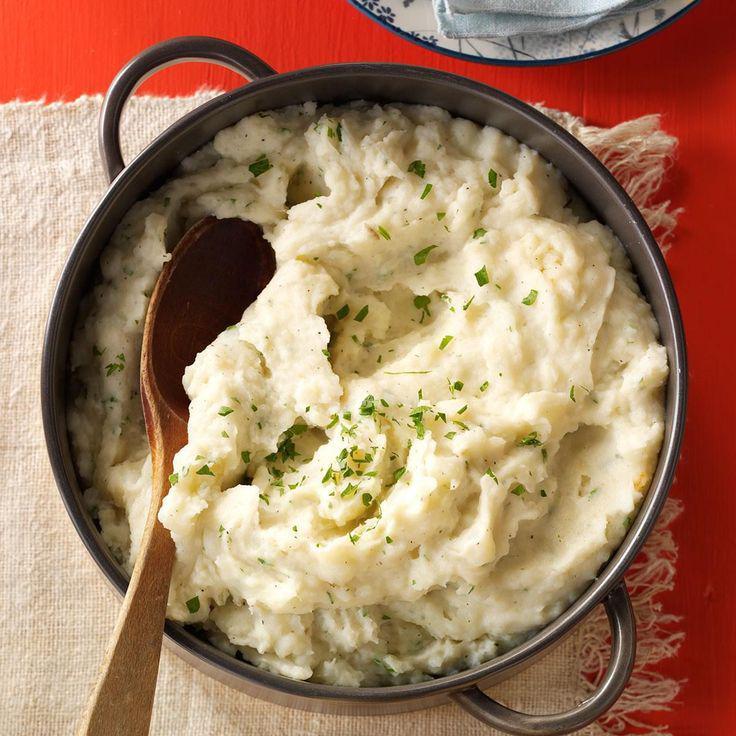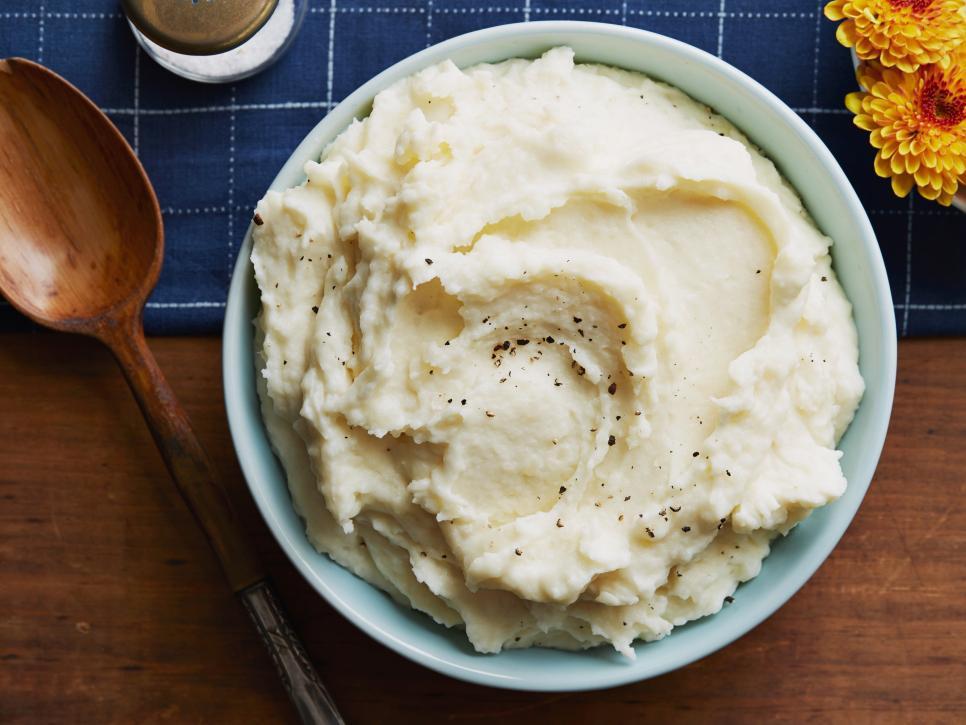The first image is the image on the left, the second image is the image on the right. Evaluate the accuracy of this statement regarding the images: "Each image shows a spoon with a bowl of mashed potatoes, and the spoons are made of the same type of material.". Is it true? Answer yes or no. Yes. The first image is the image on the left, the second image is the image on the right. Evaluate the accuracy of this statement regarding the images: "The dish in the image on the left has a spoon in it.". Is it true? Answer yes or no. Yes. 